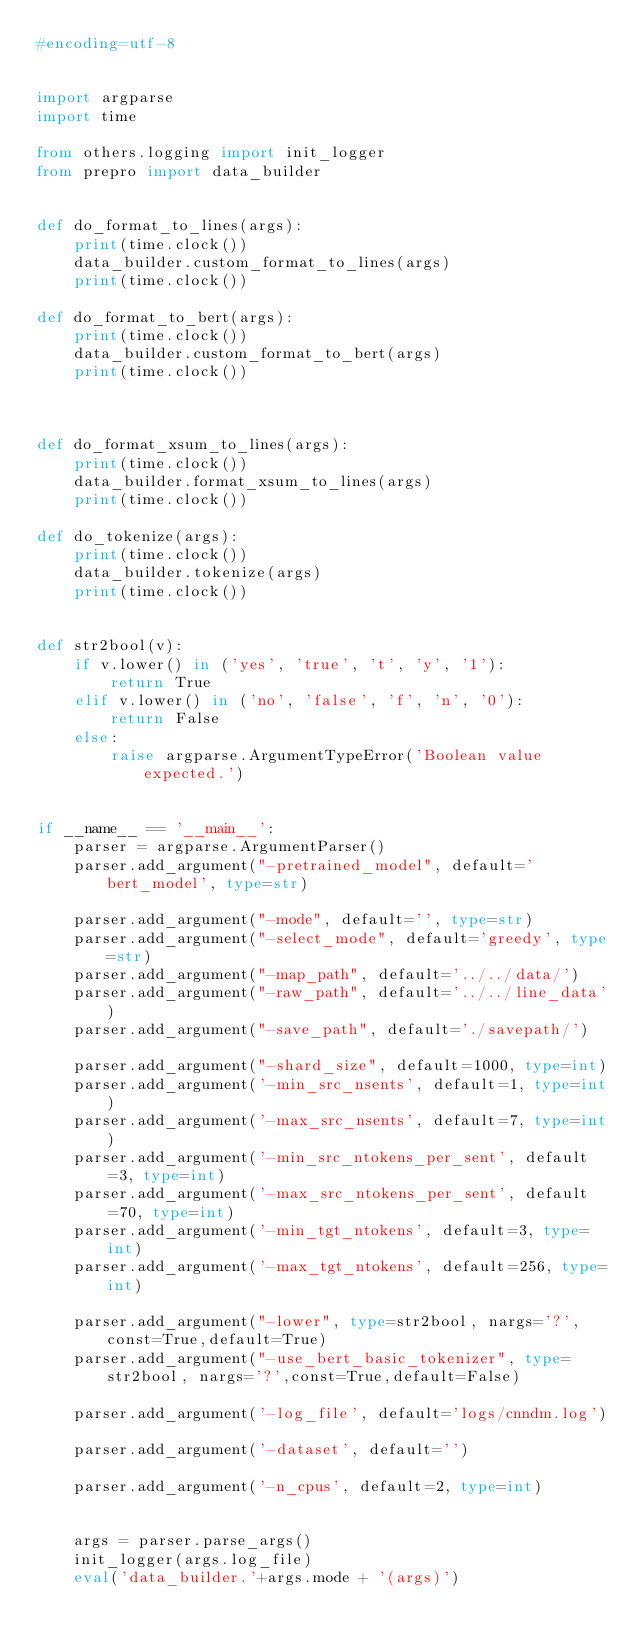Convert code to text. <code><loc_0><loc_0><loc_500><loc_500><_Python_>#encoding=utf-8


import argparse
import time

from others.logging import init_logger
from prepro import data_builder


def do_format_to_lines(args):
    print(time.clock())
    data_builder.custom_format_to_lines(args)
    print(time.clock())

def do_format_to_bert(args):
    print(time.clock())
    data_builder.custom_format_to_bert(args)
    print(time.clock())



def do_format_xsum_to_lines(args):
    print(time.clock())
    data_builder.format_xsum_to_lines(args)
    print(time.clock())

def do_tokenize(args):
    print(time.clock())
    data_builder.tokenize(args)
    print(time.clock())


def str2bool(v):
    if v.lower() in ('yes', 'true', 't', 'y', '1'):
        return True
    elif v.lower() in ('no', 'false', 'f', 'n', '0'):
        return False
    else:
        raise argparse.ArgumentTypeError('Boolean value expected.')


if __name__ == '__main__':
    parser = argparse.ArgumentParser()
    parser.add_argument("-pretrained_model", default='bert_model', type=str)

    parser.add_argument("-mode", default='', type=str)
    parser.add_argument("-select_mode", default='greedy', type=str)
    parser.add_argument("-map_path", default='../../data/')
    parser.add_argument("-raw_path", default='../../line_data')
    parser.add_argument("-save_path", default='./savepath/')

    parser.add_argument("-shard_size", default=1000, type=int)
    parser.add_argument('-min_src_nsents', default=1, type=int)
    parser.add_argument('-max_src_nsents', default=7, type=int)
    parser.add_argument('-min_src_ntokens_per_sent', default=3, type=int)
    parser.add_argument('-max_src_ntokens_per_sent', default=70, type=int)
    parser.add_argument('-min_tgt_ntokens', default=3, type=int)
    parser.add_argument('-max_tgt_ntokens', default=256, type=int)

    parser.add_argument("-lower", type=str2bool, nargs='?',const=True,default=True)
    parser.add_argument("-use_bert_basic_tokenizer", type=str2bool, nargs='?',const=True,default=False)

    parser.add_argument('-log_file', default='logs/cnndm.log')

    parser.add_argument('-dataset', default='')

    parser.add_argument('-n_cpus', default=2, type=int)


    args = parser.parse_args()
    init_logger(args.log_file)
    eval('data_builder.'+args.mode + '(args)')
</code> 